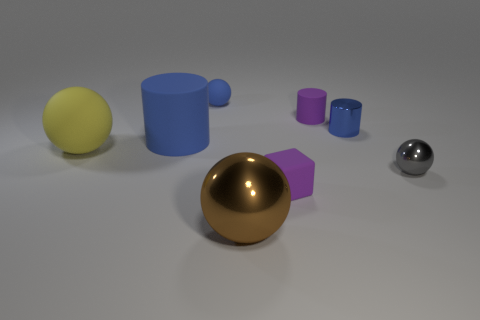How many matte objects are purple cubes or big yellow balls?
Give a very brief answer. 2. What number of small matte objects are there?
Your response must be concise. 3. Do the ball that is to the right of the big brown shiny ball and the big brown sphere in front of the rubber cube have the same material?
Your answer should be very brief. Yes. There is a large rubber object that is the same shape as the small blue rubber object; what color is it?
Offer a terse response. Yellow. What is the small sphere behind the blue cylinder that is on the left side of the brown object made of?
Ensure brevity in your answer.  Rubber. Is the shape of the tiny purple object that is behind the gray thing the same as the purple thing in front of the tiny purple matte cylinder?
Provide a short and direct response. No. What size is the ball that is both in front of the yellow ball and on the left side of the rubber cube?
Give a very brief answer. Large. What number of other things are the same color as the small rubber cylinder?
Your answer should be compact. 1. Does the large ball that is left of the big metal sphere have the same material as the big cylinder?
Your response must be concise. Yes. Is there any other thing that is the same size as the blue matte cylinder?
Give a very brief answer. Yes. 